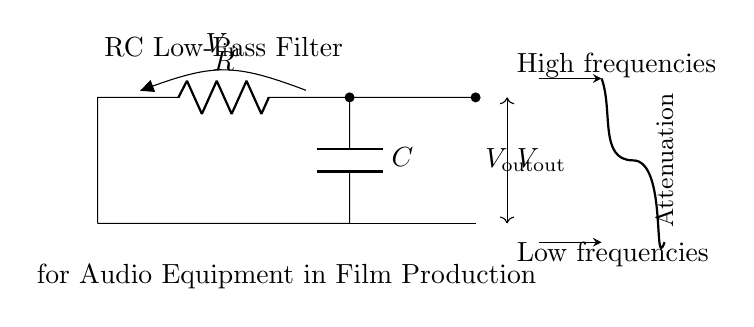What is the function of the capacitor in this circuit? The capacitor in this RC low-pass filter allows low-frequency signals to pass while attenuating high-frequency signals. This works by charging and discharging over time, effectively smoothing the output voltage.
Answer: Allowing low frequencies What is the value of Vout when only low frequencies are present? When only low frequencies are present, Vout is approximately equal to Vin because the capacitor does not significantly impede the low frequencies, resulting in minimal voltage drop across the resistor.
Answer: Equal to Vin What happens to Vout when high frequencies are applied? When high frequencies are applied, Vout decreases significantly due to the capacitor's impedance at high frequencies, leading to a larger voltage drop across the resistor. The output is thus low.
Answer: It decreases significantly What type of filter does this circuit represent? This circuit represents a low-pass filter because it allows low-frequency signals to pass while attenuating high-frequency signals. The arrangement of the resistor and capacitor defines this behavior.
Answer: Low-pass filter What are the two types of frequencies indicated in the circuit? The circuit indicates high frequencies and low frequencies, differentiating the types of signals that the filter affects. This distinction helps in understanding how the circuit behaves to different frequency components.
Answer: High frequencies and low frequencies What role does the resistor play in this circuit? The resistor in the RC low-pass filter determines the time constant when combined with the capacitor, affecting how quickly the output responds to changes in input voltage. It also impacts the output voltage level for varying frequencies.
Answer: Determines time constant What does attenuation refer to in this context? Attenuation refers to the reduction of signal strength as the frequency increases, particularly affecting how high-frequency signals are diminished in the output compared to the input. In this circuit, it describes how efficiently the filter suppresses unwanted frequencies.
Answer: Reduction of signal strength 